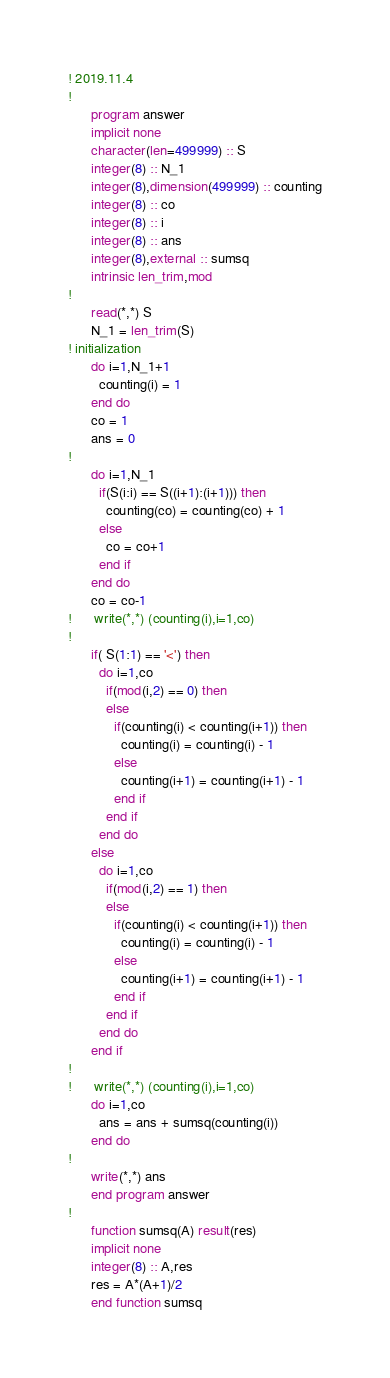<code> <loc_0><loc_0><loc_500><loc_500><_FORTRAN_>! 2019.11.4
!
      program answer
      implicit none
      character(len=499999) :: S
      integer(8) :: N_1
      integer(8),dimension(499999) :: counting
      integer(8) :: co
      integer(8) :: i
      integer(8) :: ans
      integer(8),external :: sumsq
      intrinsic len_trim,mod
!
      read(*,*) S
      N_1 = len_trim(S)
! initialization
      do i=1,N_1+1
        counting(i) = 1
      end do
      co = 1
      ans = 0
!
      do i=1,N_1
        if(S(i:i) == S((i+1):(i+1))) then
          counting(co) = counting(co) + 1
        else
          co = co+1
        end if
      end do
      co = co-1
!      write(*,*) (counting(i),i=1,co)
!
      if( S(1:1) == '<') then
        do i=1,co
          if(mod(i,2) == 0) then
          else
            if(counting(i) < counting(i+1)) then
              counting(i) = counting(i) - 1
            else
              counting(i+1) = counting(i+1) - 1
            end if
          end if
        end do
      else
        do i=1,co
          if(mod(i,2) == 1) then
          else
            if(counting(i) < counting(i+1)) then
              counting(i) = counting(i) - 1
            else
              counting(i+1) = counting(i+1) - 1
            end if
          end if
        end do
      end if
!
!      write(*,*) (counting(i),i=1,co)
      do i=1,co
        ans = ans + sumsq(counting(i))
      end do
!
      write(*,*) ans
      end program answer
!
      function sumsq(A) result(res)
      implicit none
      integer(8) :: A,res
      res = A*(A+1)/2
      end function sumsq </code> 